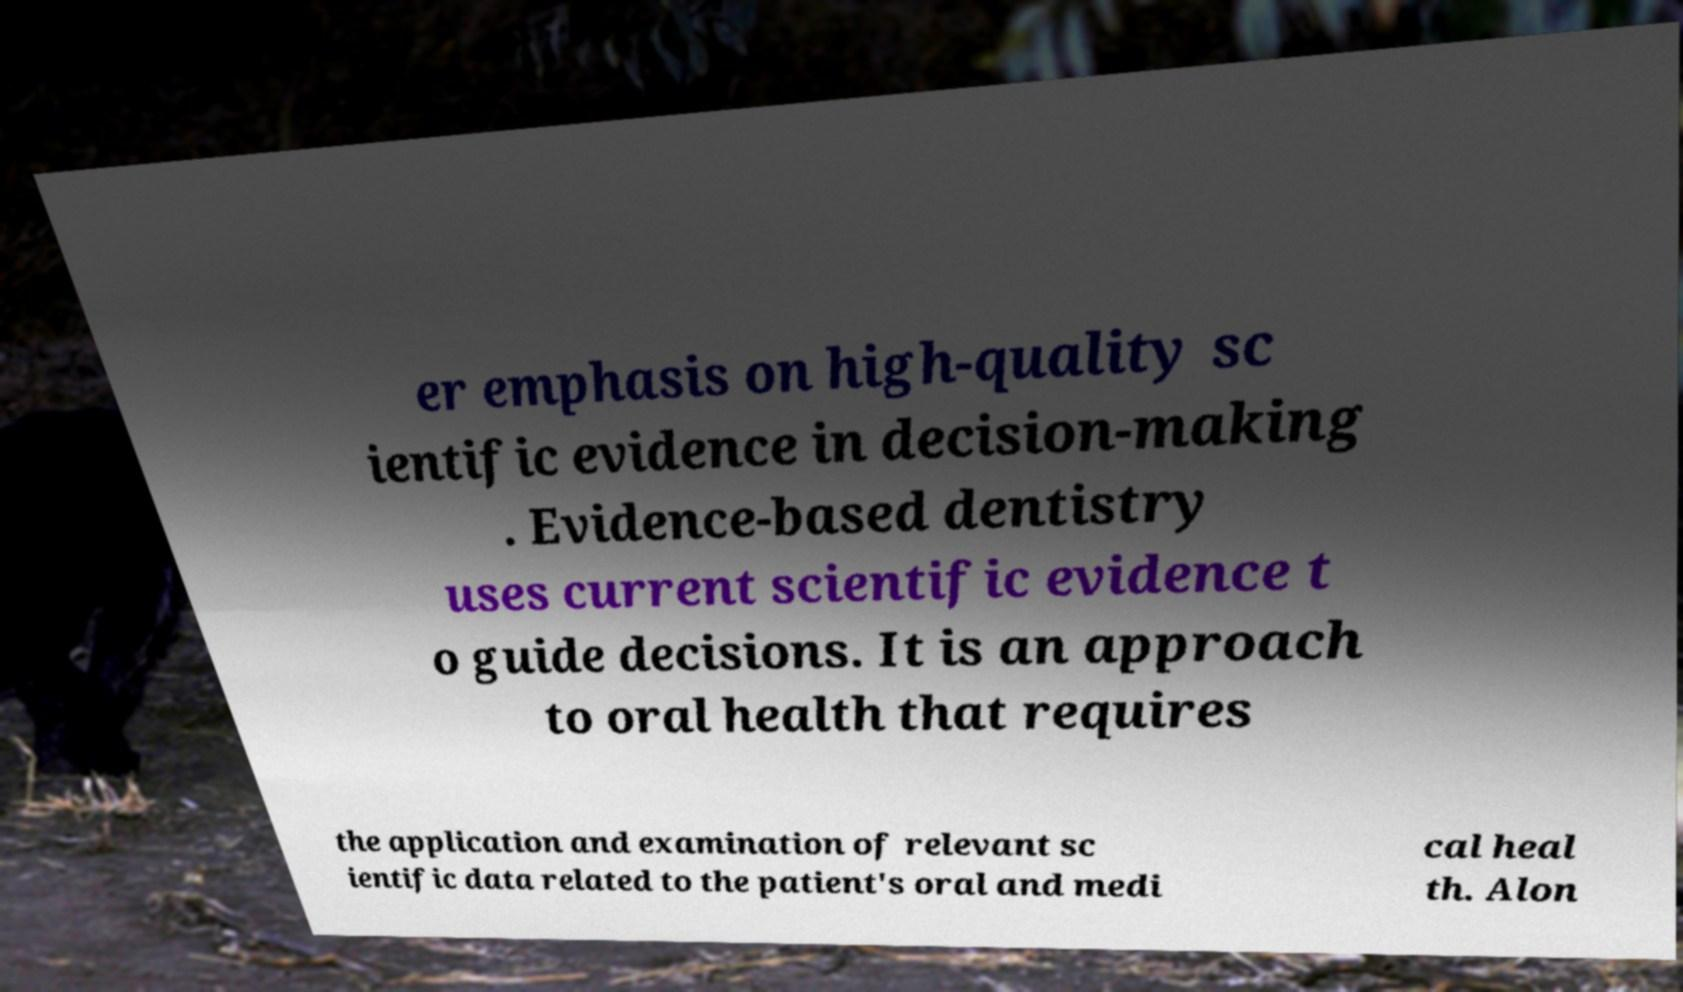Could you extract and type out the text from this image? er emphasis on high-quality sc ientific evidence in decision-making . Evidence-based dentistry uses current scientific evidence t o guide decisions. It is an approach to oral health that requires the application and examination of relevant sc ientific data related to the patient's oral and medi cal heal th. Alon 